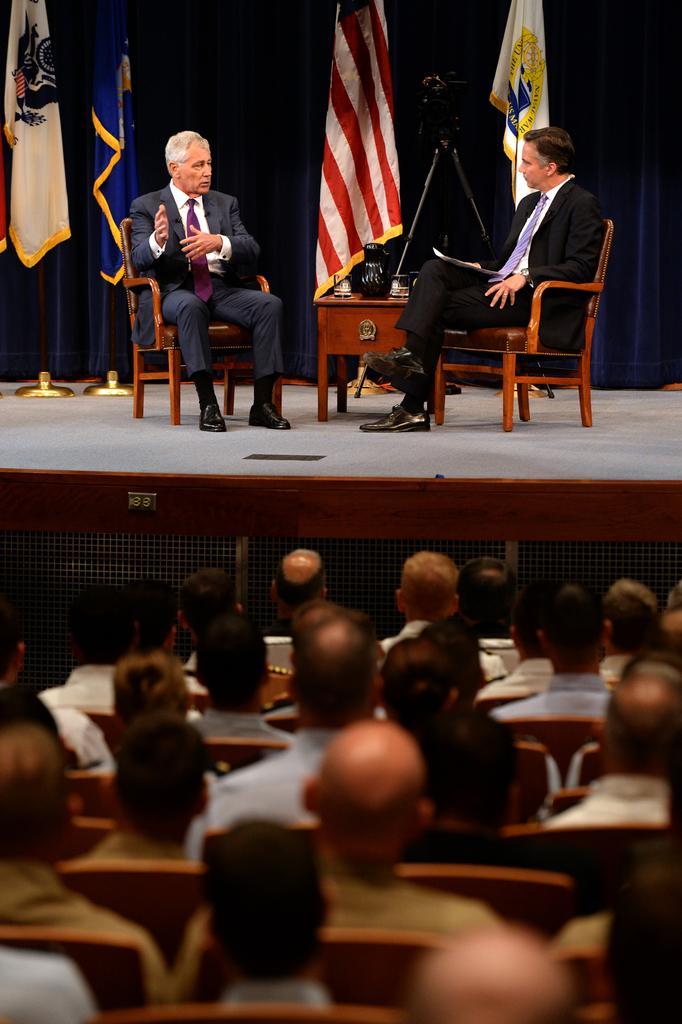How would you summarize this image in a sentence or two? This is a picture of a hall in which the people are sitting in the chairs and on the stage we have two chairs and a table in between and on chairs there are two people sitting and on the table we some things and behind them there is a blue curtain to which there are some flags. 